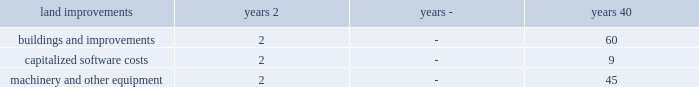Cash and cash equivalents - the carrying amounts of cash and cash equivalents approximate fair value due to the short-term nature of these assets , which have original maturity dates of 90 days or less .
Concentration risk - the company 2019s assets that are exposed to concentrations of credit risk consist primarily of cash and cash equivalents .
The company places its cash and cash equivalents with reputable financial institutions and limits the amount of credit exposure with any one of them .
The company regularly evaluates the creditworthiness of these financial institutions and minimizes this credit risk by entering into transactions with high- quality counterparties , limiting the exposure to each counterparty , and monitoring the financial condition of its counterparties .
In connection with its u.s .
Government contracts , the company is required to procure certain raw materials , components , and parts from supply sources approved by the u.s .
Government .
Only one supplier may exist for certain components and parts required to manufacture the company's products .
Accounts receivable - accounts receivable include amounts billed and currently due from customers , amounts currently due but unbilled , certain estimated contract change amounts , claims or requests for equitable adjustment in negotiation that are probable of recovery , and amounts retained by the customer pending contract completion .
Inventoried costs - inventoried costs primarily relate to production costs of contracts in process and company owned raw materials , which are stated at the lower of cost or net realizable value , generally using the average cost method .
Under the company's u.s .
Government contracts , the customer asserts title to , or a security interest in , inventories related to such contracts as a result of contract advances , performance-based payments , and progress payments .
In accordance with industry practice , inventoried costs are classified as a current asset and include amounts related to contracts having production cycles longer than one year .
Inventoried costs also include work in process under contracts that recognize revenues using labor dollars as the basis of the percentage-of-completion calculation .
These costs represent accumulated contract costs less cost of sales as calculated using the percentage-of-completion method , not in excess of recoverable value .
Advance payments and billings in excess of revenues - payments received in excess of inventoried costs and revenues are recorded as advance payment liabilities .
Property , plant , and equipment - depreciable properties owned by the company are recorded at cost and depreciated over the estimated useful lives of individual assets .
Major improvements are capitalized while expenditures for maintenance , repairs , and minor improvements are expensed .
Costs incurred for computer software developed or obtained for internal use are capitalized and amortized over the expected useful life of the software , not to exceed nine years .
Leasehold improvements are amortized over the shorter of their useful lives or the term of the lease .
The remaining assets are depreciated using the straight-line method , with the following lives: .
The company evaluates the recoverability of its property , plant , and equipment when there are changes in economic circumstances or business objectives that indicate the carrying value may not be recoverable .
The company's evaluations include estimated future cash flows , profitability , and other factors affecting fair value .
As these assumptions and estimates may change over time , it may or may not be necessary to record impairment charges .
Leases - the company uses its incremental borrowing rate in the assessment of lease classification as capital or operating and defines the initial lease term to include renewal options determined to be reasonably assured .
The company conducts operations primarily under operating leases. .
What is the difference in depreciation years of the maximum length for land improvements and buildings and improvements? 
Computations: (60 - 40)
Answer: 20.0. Cash and cash equivalents - the carrying amounts of cash and cash equivalents approximate fair value due to the short-term nature of these assets , which have original maturity dates of 90 days or less .
Concentration risk - the company 2019s assets that are exposed to concentrations of credit risk consist primarily of cash and cash equivalents .
The company places its cash and cash equivalents with reputable financial institutions and limits the amount of credit exposure with any one of them .
The company regularly evaluates the creditworthiness of these financial institutions and minimizes this credit risk by entering into transactions with high- quality counterparties , limiting the exposure to each counterparty , and monitoring the financial condition of its counterparties .
In connection with its u.s .
Government contracts , the company is required to procure certain raw materials , components , and parts from supply sources approved by the u.s .
Government .
Only one supplier may exist for certain components and parts required to manufacture the company's products .
Accounts receivable - accounts receivable include amounts billed and currently due from customers , amounts currently due but unbilled , certain estimated contract change amounts , claims or requests for equitable adjustment in negotiation that are probable of recovery , and amounts retained by the customer pending contract completion .
Inventoried costs - inventoried costs primarily relate to production costs of contracts in process and company owned raw materials , which are stated at the lower of cost or net realizable value , generally using the average cost method .
Under the company's u.s .
Government contracts , the customer asserts title to , or a security interest in , inventories related to such contracts as a result of contract advances , performance-based payments , and progress payments .
In accordance with industry practice , inventoried costs are classified as a current asset and include amounts related to contracts having production cycles longer than one year .
Inventoried costs also include work in process under contracts that recognize revenues using labor dollars as the basis of the percentage-of-completion calculation .
These costs represent accumulated contract costs less cost of sales as calculated using the percentage-of-completion method , not in excess of recoverable value .
Advance payments and billings in excess of revenues - payments received in excess of inventoried costs and revenues are recorded as advance payment liabilities .
Property , plant , and equipment - depreciable properties owned by the company are recorded at cost and depreciated over the estimated useful lives of individual assets .
Major improvements are capitalized while expenditures for maintenance , repairs , and minor improvements are expensed .
Costs incurred for computer software developed or obtained for internal use are capitalized and amortized over the expected useful life of the software , not to exceed nine years .
Leasehold improvements are amortized over the shorter of their useful lives or the term of the lease .
The remaining assets are depreciated using the straight-line method , with the following lives: .
The company evaluates the recoverability of its property , plant , and equipment when there are changes in economic circumstances or business objectives that indicate the carrying value may not be recoverable .
The company's evaluations include estimated future cash flows , profitability , and other factors affecting fair value .
As these assumptions and estimates may change over time , it may or may not be necessary to record impairment charges .
Leases - the company uses its incremental borrowing rate in the assessment of lease classification as capital or operating and defines the initial lease term to include renewal options determined to be reasonably assured .
The company conducts operations primarily under operating leases. .
What is the minimum yearly depreciation rate for capitalized software costs? 
Computations: (100 / 9)
Answer: 11.11111. 